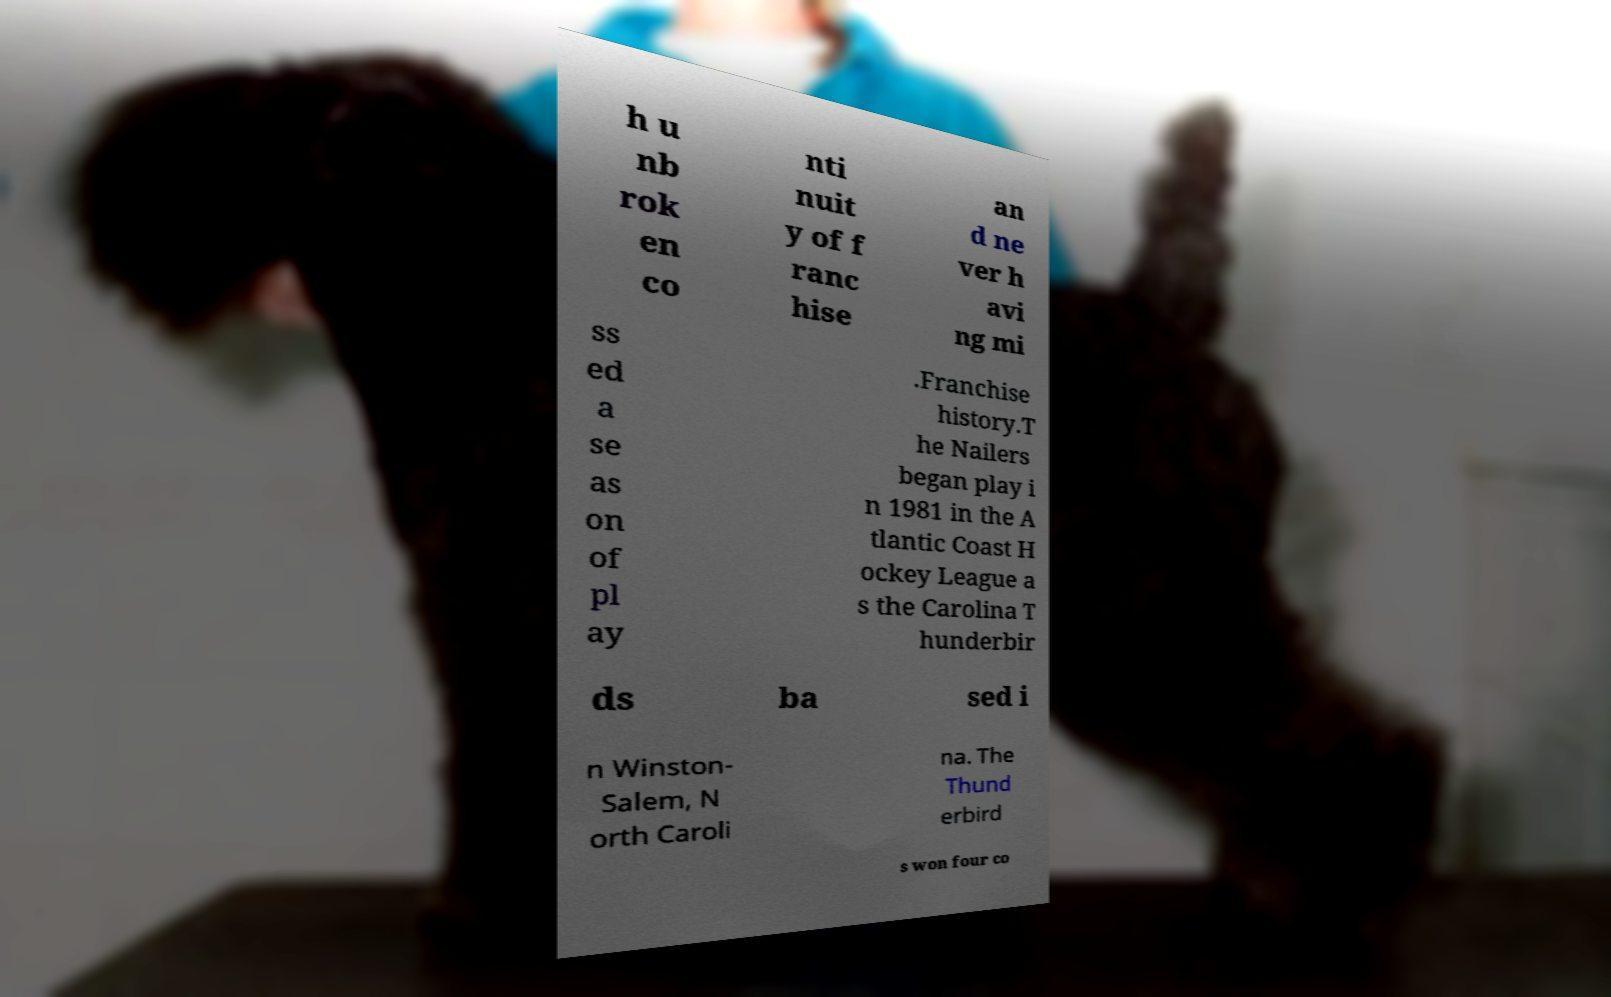Please read and relay the text visible in this image. What does it say? h u nb rok en co nti nuit y of f ranc hise an d ne ver h avi ng mi ss ed a se as on of pl ay .Franchise history.T he Nailers began play i n 1981 in the A tlantic Coast H ockey League a s the Carolina T hunderbir ds ba sed i n Winston- Salem, N orth Caroli na. The Thund erbird s won four co 